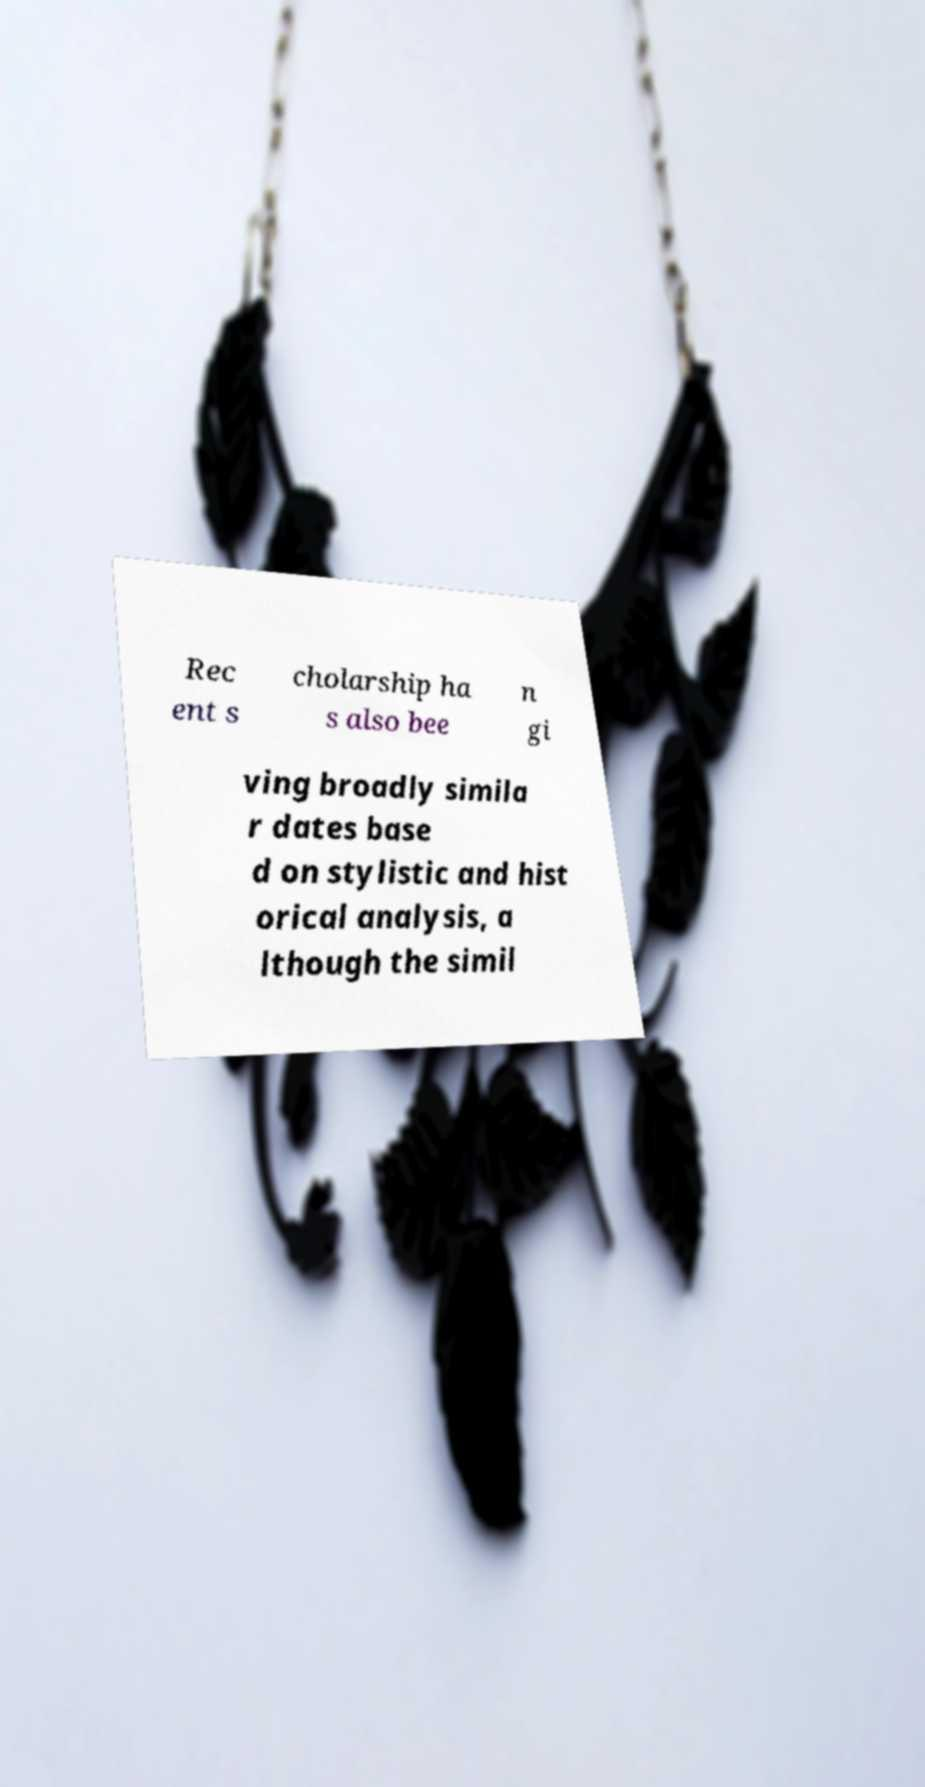I need the written content from this picture converted into text. Can you do that? Rec ent s cholarship ha s also bee n gi ving broadly simila r dates base d on stylistic and hist orical analysis, a lthough the simil 